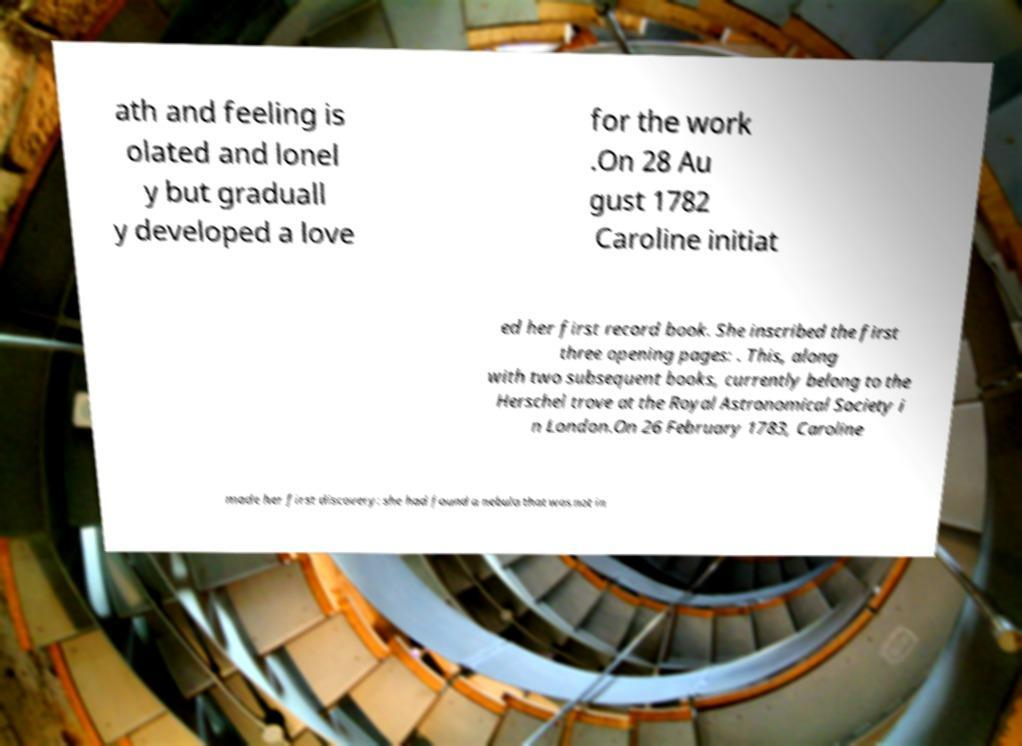Can you read and provide the text displayed in the image?This photo seems to have some interesting text. Can you extract and type it out for me? ath and feeling is olated and lonel y but graduall y developed a love for the work .On 28 Au gust 1782 Caroline initiat ed her first record book. She inscribed the first three opening pages: . This, along with two subsequent books, currently belong to the Herschel trove at the Royal Astronomical Society i n London.On 26 February 1783, Caroline made her first discovery: she had found a nebula that was not in 